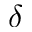Convert formula to latex. <formula><loc_0><loc_0><loc_500><loc_500>\delta</formula> 